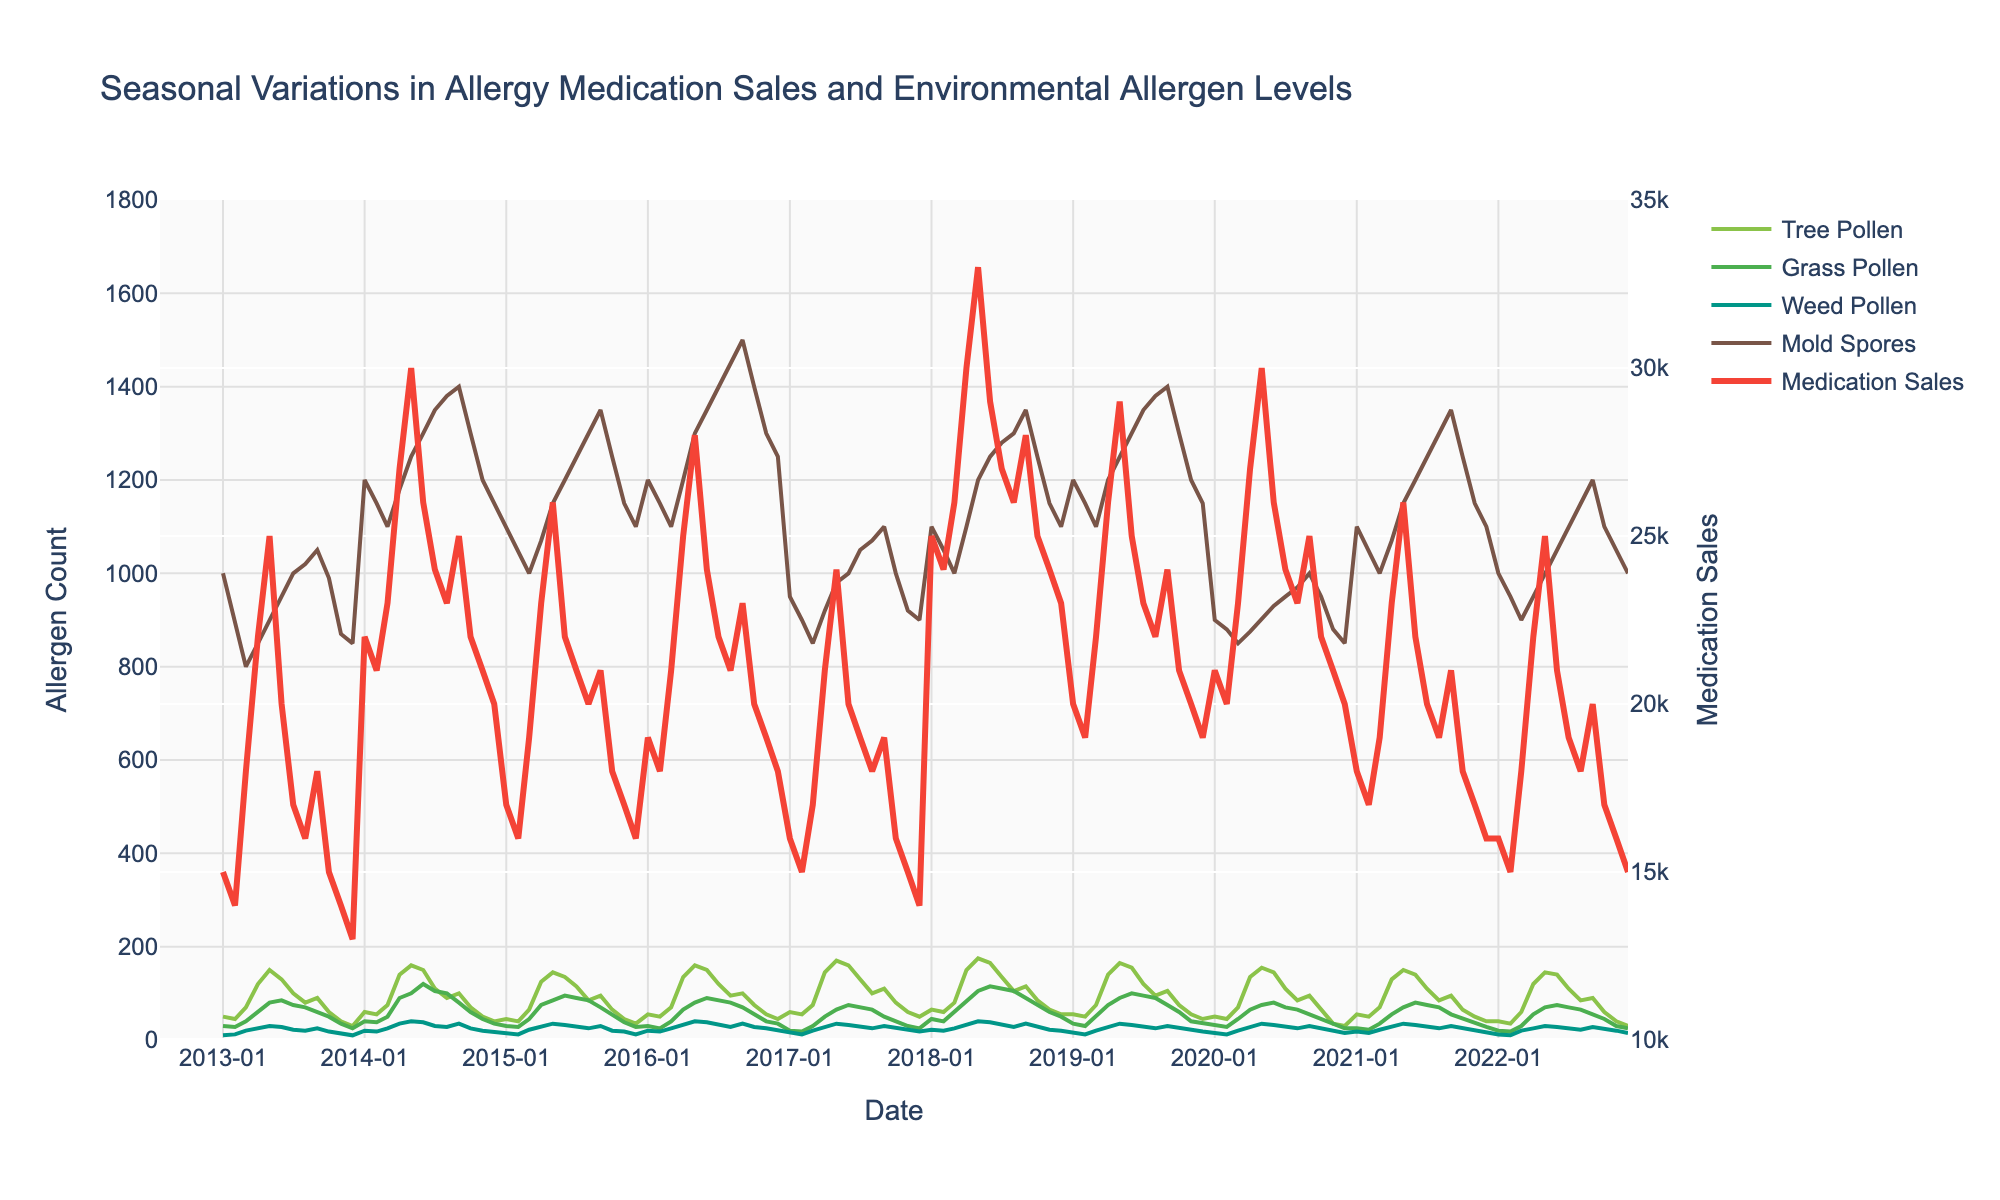What is the title of the plot? The title of the plot appears at the top of the figure, showing the main subject of the data visualized.
Answer: Seasonal Variations in Allergy Medication Sales and Environmental Allergen Levels What does the red line in the plot represent? The legend on the right side of the plot provides the color-coding of the lines, and the red line is labeled under the "Medication Sales" category.
Answer: Medication Sales During which month and year did Miami have its highest Tree Pollen count? By examining the line corresponding to Tree Pollen count as indicated by the green color in the legend and following it to its peak value in the period of Miami's data, we can identify the highest count for Miami.
Answer: May 2018 How do Allergy Medication Sales in New York in June 2013 compare to those in June 2014? Trace the red line representing Medication Sales during June 2013 and June 2014 in New York by focusing on the specified months in the x-axis. The values indicate the difference.
Answer: Decreased by 6,000 Compare the Grass Pollen counts between Los Angeles in June 2014 and Houston in June 2016. Which city had a higher count? Examine the green line corresponding to Grass Pollen count for Los Angeles in June 2014 and Houston in June 2016 by identifying the values on the y-axis.
Answer: Houston When did Seattle experience a peak in Weed Pollen count? Identify the line corresponding to Weed Pollen count with the appropriate color and track it to its highest point during the examined period for Seattle.
Answer: May 2017 What was the Tree Pollen count in April 2019 in Dallas? Follow the green line representing Tree Pollen count to the data point of April 2019 and read off the y-axis value.
Answer: 140 Which city had the lowest Mold Spore count in the entire dataset, and during which month and year did it occur? By scanning the lowest points of the brown line (Mold Spores) across all cities and identifying the lowest value along with its timestamp.
Answer: Phoenix, February 2020 What is the general trend of Allergy Medication Sales in Boston from January to December 2022? By following the red line representing Medication Sales for Boston over the specified period, we can observe the overall increase or decrease.
Answer: General decreasing trend Are Tree Pollen counts generally higher in summer or winter? By tracking the green line (Tree Pollen count) across multiple years and observing the values during summer months versus winter months for consistency.
Answer: Summer 